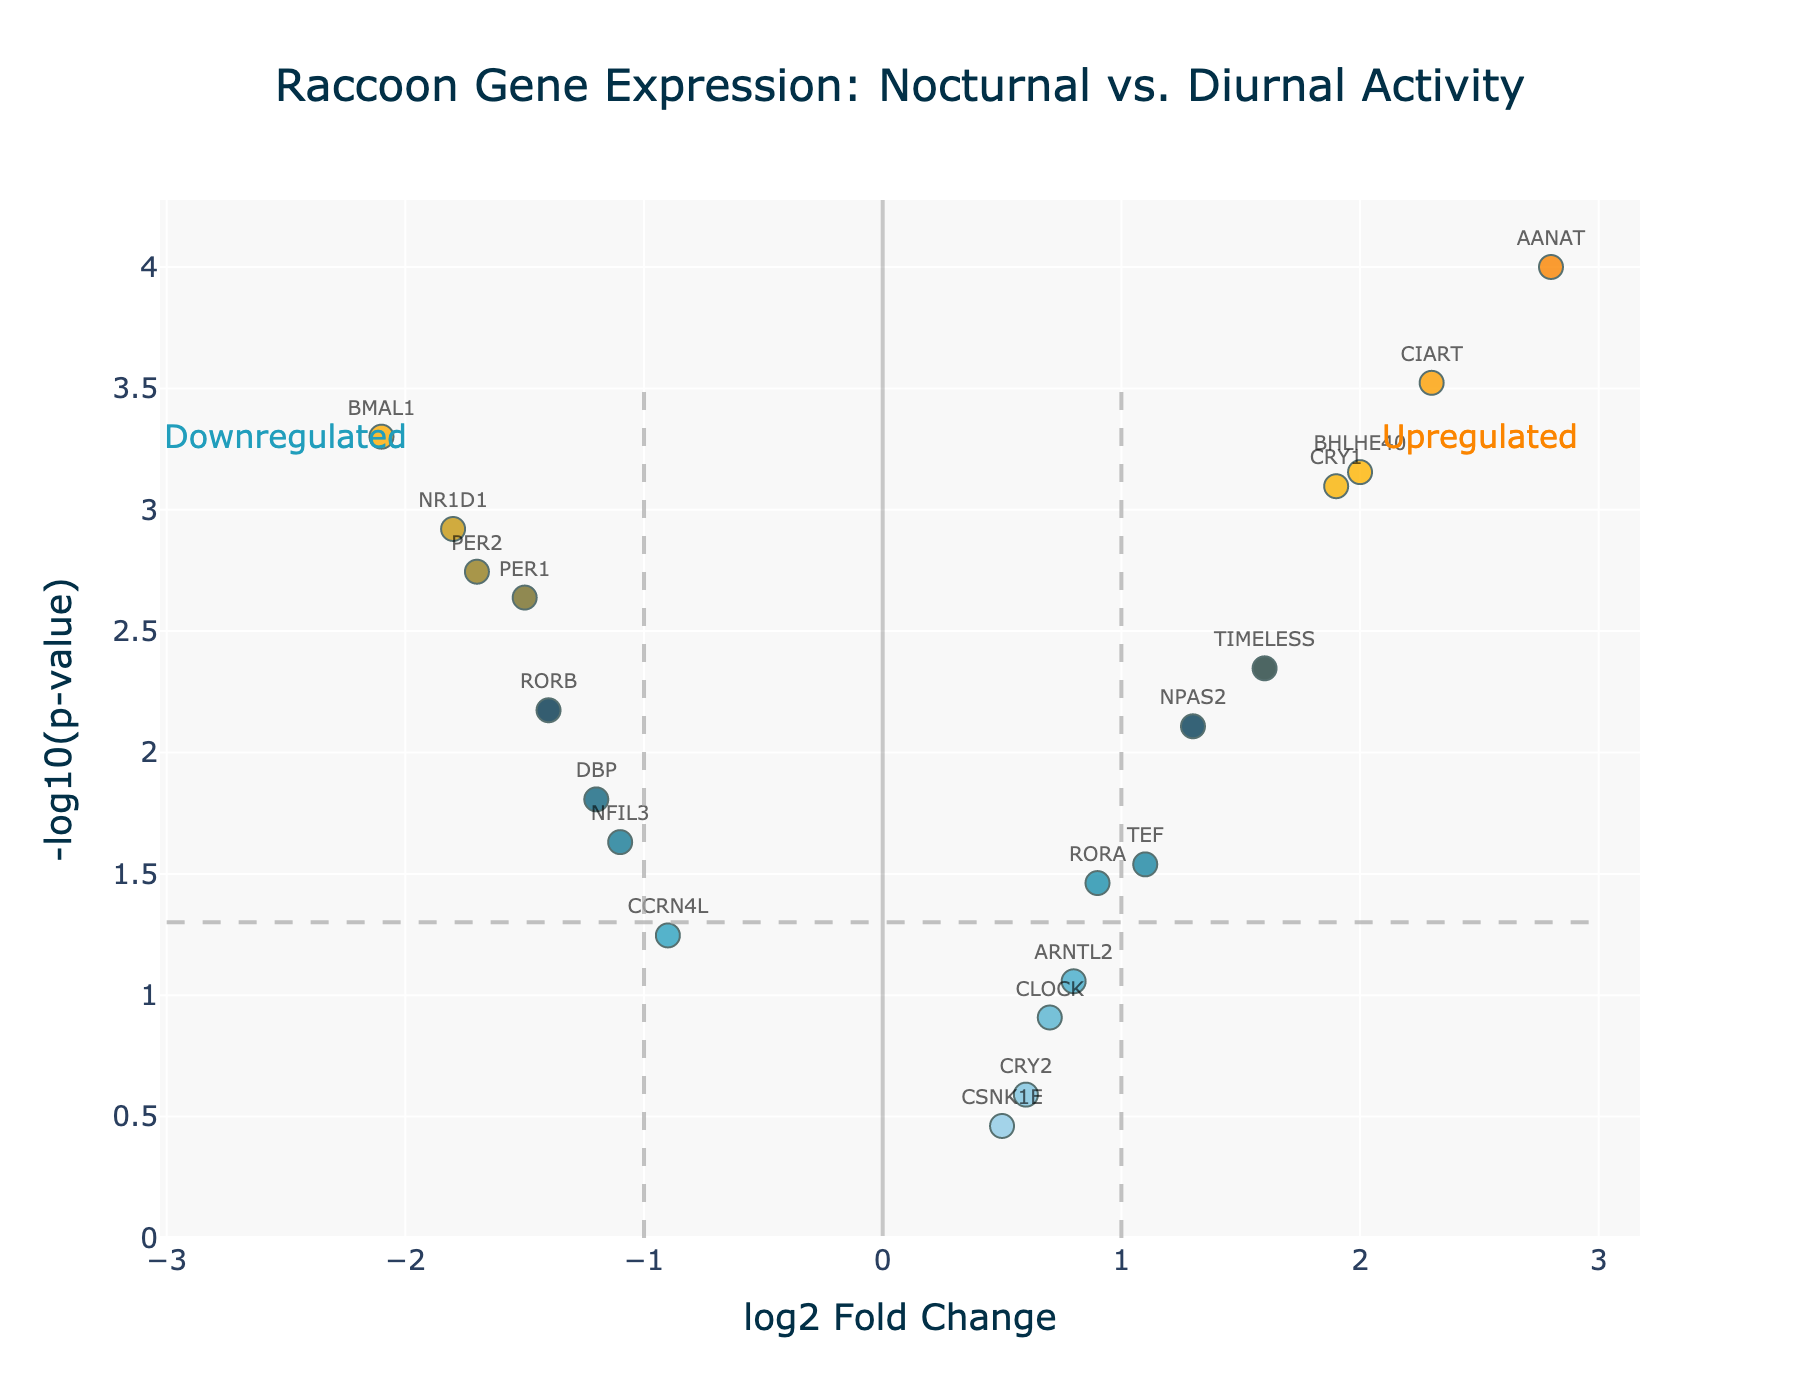What's the title of the figure? The title is usually displayed at the top center of the plot. It provides a brief description of what the plot represents. For this figure, it is clearly stated at the top.
Answer: Raccoon Gene Expression: Nocturnal vs. Diurnal Activity What are the axes labels on the plot? The axes labels help in understanding what each axis represents. Typically, these labels are found just outside the plotting area along the respective axis. In this figure, the x-axis represents log2 Fold Change, and the y-axis represents -log10(p-value).
Answer: log2 Fold Change, -log10(p-value) How many genes show a significant log2 fold change greater than 1? To find the number of genes with significant log2 fold change greater than 1, we look for markers located to the right of the vertical line at log2 fold change = 1 and below the horizontal line at p-value = 0.05 (or -log10(p-value) above 1.3).
Answer: 4 Which gene has the highest log2 fold change? We identify the highest point along the x-axis representing the maximal log2 fold change. The accompanying label of that marker indicates the gene.
Answer: AANAT Are there more upregulated or downregulated genes among the significant ones? Upregulated genes have a positive log2 fold change, while downregulated genes have a negative log2 fold change. Count the number of significant genes on each side of log2FC = 0.
Answer: More downregulated Which gene has the lowest p-value and what is its log2 fold change? The gene with the lowest p-value will be the highest point on the y-axis. Identify the gene label and read its corresponding x-axis value for the log2 fold change.
Answer: AANAT, 2.8 Compare the log2 fold change of PER1 and TIMELESS. Which is higher? First, locate PER1 and TIMELESS on the plot by their markers and labels. Then, compare their positions along the x-axis, where the higher value represents the greater log2 fold change.
Answer: TIMELESS Which genes are upregulated and have their p-value less than 0.01? Upregulated genes have positive log2 fold change values. Filter these genes further by checking if their -log10(p-value) is greater than 2 (indicating p-value < 0.01).
Answer: AANAT, CRY1, CIART, BHLHE40, TIMELESS What do the annotations "Upregulated" and "Downregulated" mean in this plot? These annotations indicate the direction of gene expression changes. "Upregulated" means gene expression is higher during nocturnal activity (positive log2 fold change), and "Downregulated" means gene expression is lower during nocturnal activity (negative log2 fold change).
Answer: Higher or lower expression during nocturnal activity 